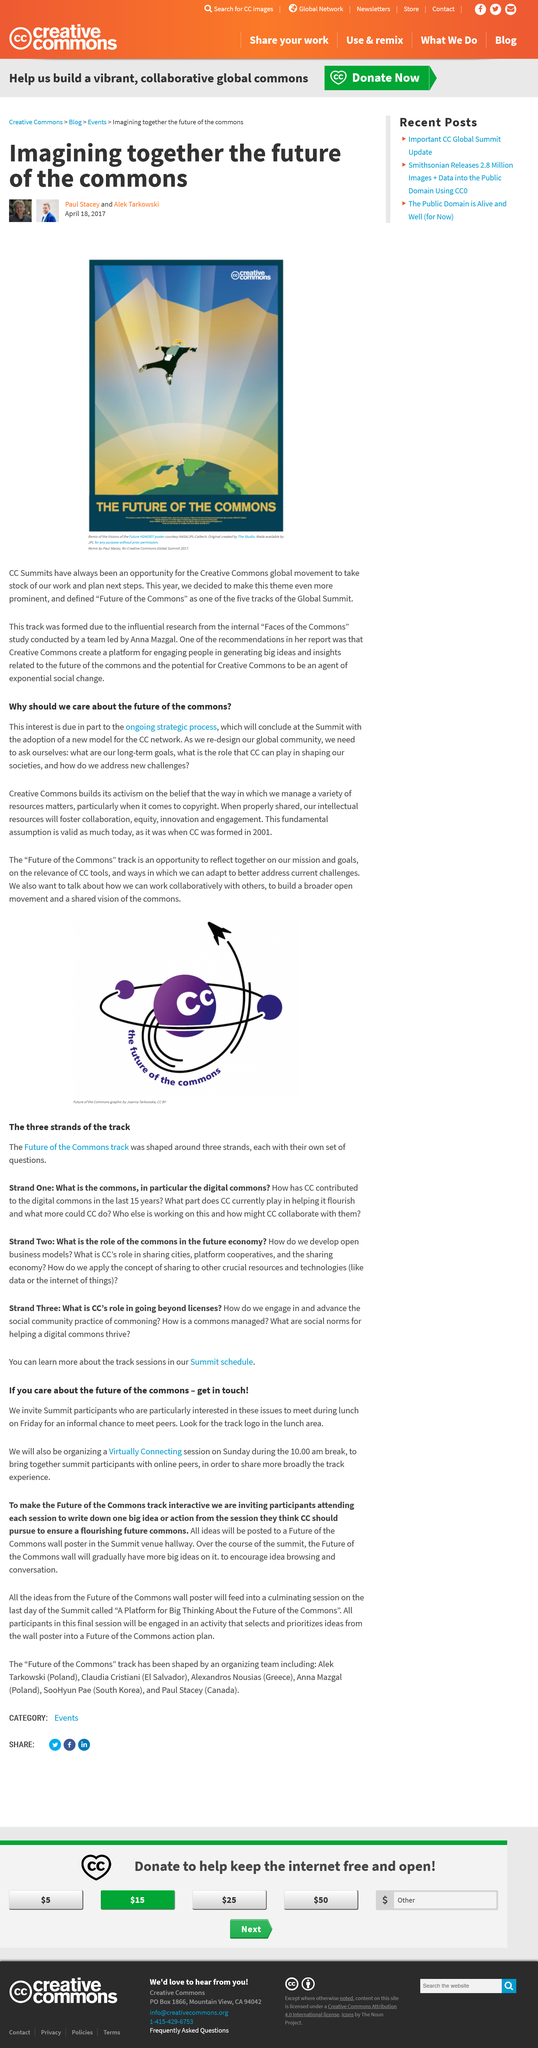Give some essential details in this illustration. On Sunday during the 10 AM break, there will be a virtual connecting session. The Future of the Commons summit will have five tracks. Anna Mazgal conducted the "Faces of the Commons" study. The Future of the Commons summit is being held in 2017. The Virtually Connected session will enable summit participants to connect and collaborate with online peers to share their experiences and insights from the summit tracks. 